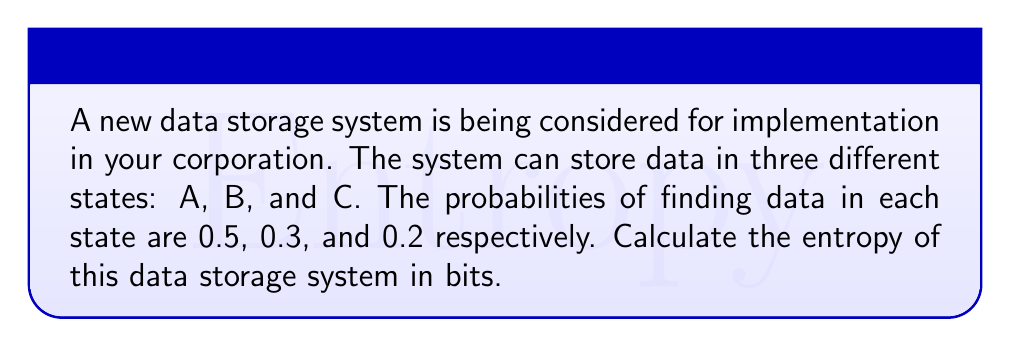What is the answer to this math problem? To calculate the entropy of the data storage system, we'll use the Shannon entropy formula:

$$S = -\sum_{i} p_i \log_2(p_i)$$

Where $S$ is the entropy, $p_i$ is the probability of each state, and we use $\log_2$ to get the result in bits.

Step 1: Calculate each term in the sum:
- For state A: $-0.5 \log_2(0.5)$
- For state B: $-0.3 \log_2(0.3)$
- For state C: $-0.2 \log_2(0.2)$

Step 2: Compute the logarithms:
- $\log_2(0.5) \approx -1$
- $\log_2(0.3) \approx -1.737$
- $\log_2(0.2) \approx -2.322$

Step 3: Multiply each probability by its log and sum:
$$S = (-0.5 \cdot -1) + (-0.3 \cdot -1.737) + (-0.2 \cdot -2.322)$$

Step 4: Simplify:
$$S = 0.5 + 0.5211 + 0.4644 = 1.4855$$

Therefore, the entropy of the data storage system is approximately 1.4855 bits.
Answer: $1.4855$ bits 